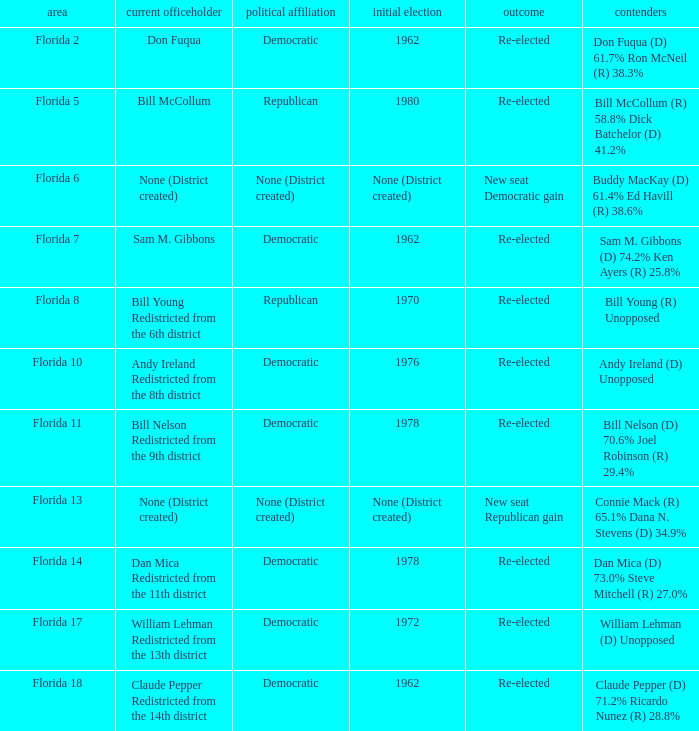What's the result with district being florida 7 Re-elected. 